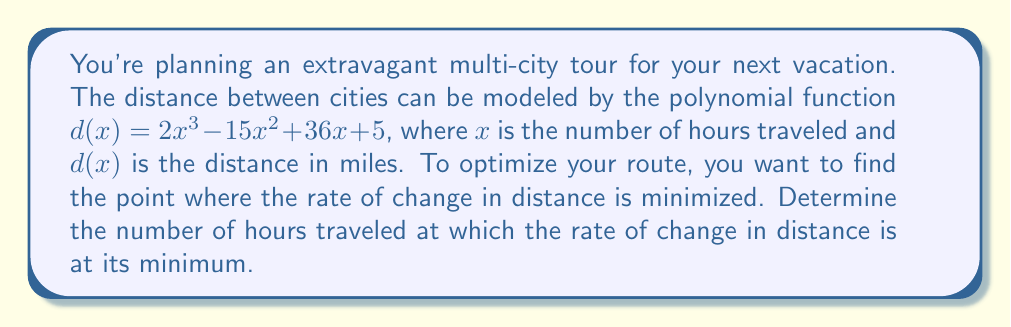Can you solve this math problem? To solve this problem, we need to follow these steps:

1) The rate of change in distance is given by the first derivative of $d(x)$. Let's call this $d'(x)$.

   $d'(x) = 6x^2 - 30x + 36$

2) To find the minimum rate of change, we need to find where the second derivative equals zero. The second derivative is:

   $d''(x) = 12x - 30$

3) Set $d''(x) = 0$ and solve for $x$:

   $12x - 30 = 0$
   $12x = 30$
   $x = \frac{30}{12} = 2.5$

4) To confirm this is a minimum (not a maximum), we can check that $d'''(x) > 0$:

   $d'''(x) = 12$, which is indeed positive.

5) Therefore, the rate of change in distance is minimized when $x = 2.5$ hours.
Answer: 2.5 hours 